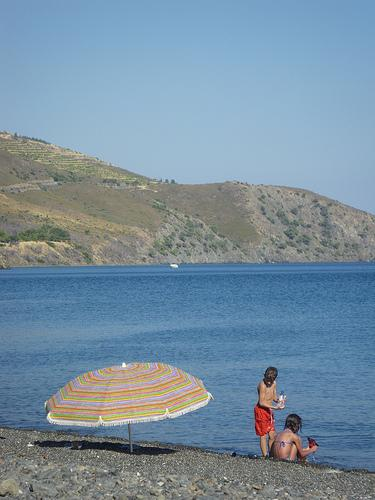Give a brief description of the main objects and landscape in the image. The scenery features children playing, a calm ocean, an umbrella, hills, and mountains near the water's edge. Briefly describe the appearance of the two children in the image. A boy is wearing red shorts and looking down, while a girl is sitting in a bathing suit with a strap visible. Describe the setting of this image in a single sentence. Children enjoy a beach day near the calm water, surrounded by hills, mountains, and an umbrella providing shade. What are the most significant aspects of the landscape in the image? The serene body of water, the hillside, and the mountain range in the background are notable landmarks. Provide a concise description of the primary activity taking place in the image. Kids in swimwear are enjoying a sunny day at the beach, playing in the sand and with a water bottle. Write a short summary of the entire scene in the image. It is a peaceful day on the beach where children are playing near an umbrella, with a calm sea, hills, and mountains as the backdrop. Mention the key components in the image and their significance. The joyous children, picturesque beach umbrella, serene water, and majestic landscape create a memorable day at the beach. Identify the main location in the image and what is happening there. A group of children playing on a beach near a calm body of water, with mountains and a hillside in the background. Mention the most prominent objects on the beach and their positions. There's a beach umbrella with a white tip, a large body of water nearby, and rocks in the sand on the left side. Describe the main elements in the image using unique details. A picturesque coastal scene featuring playful youngsters, a resplendent beach umbrella, and a stunning hillside adjacent to tranquil waters. 